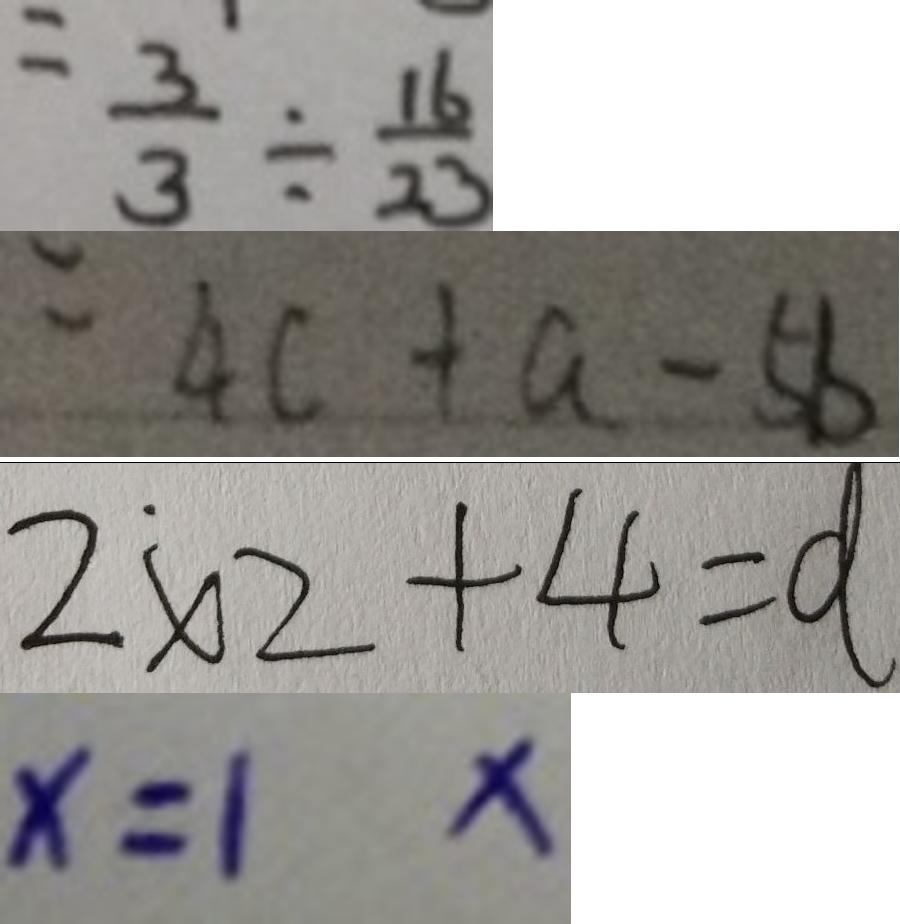Convert formula to latex. <formula><loc_0><loc_0><loc_500><loc_500>= \frac { 3 } { 3 } \div \frac { 1 6 } { 2 3 } 
 = 4 c + a - 5 b 
 2 \times 2 + 4 = d 
 x = 1 x</formula> 